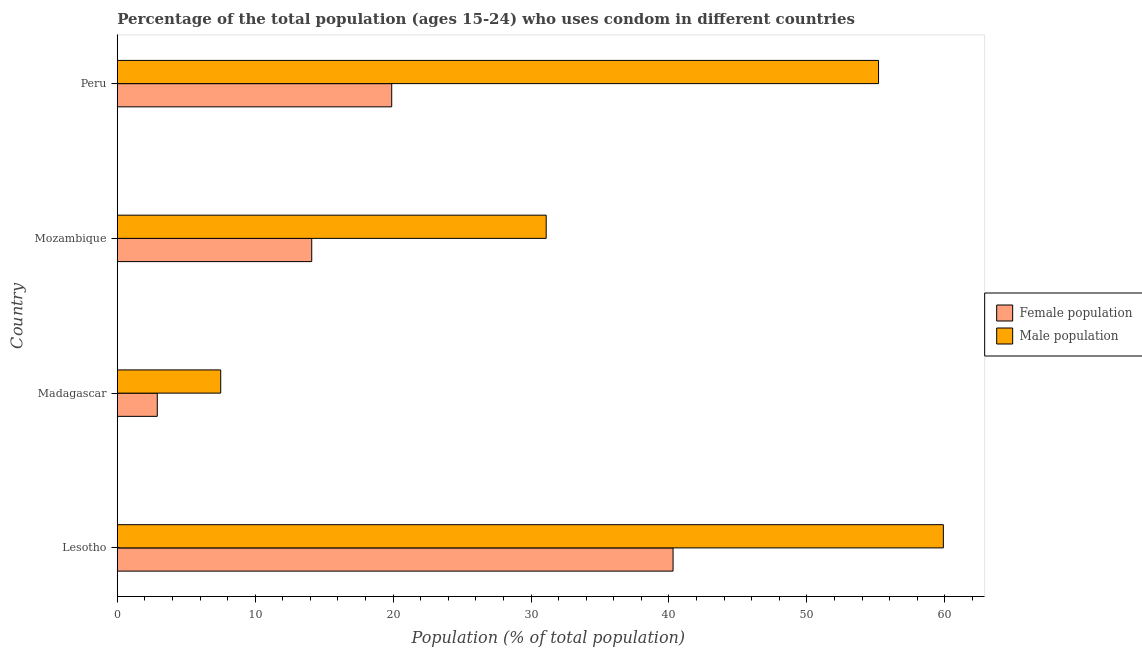How many groups of bars are there?
Make the answer very short. 4. Are the number of bars on each tick of the Y-axis equal?
Your response must be concise. Yes. How many bars are there on the 2nd tick from the bottom?
Offer a terse response. 2. What is the label of the 4th group of bars from the top?
Offer a very short reply. Lesotho. What is the male population in Lesotho?
Provide a short and direct response. 59.9. Across all countries, what is the maximum female population?
Your answer should be compact. 40.3. In which country was the male population maximum?
Make the answer very short. Lesotho. In which country was the male population minimum?
Your response must be concise. Madagascar. What is the total male population in the graph?
Ensure brevity in your answer.  153.7. What is the difference between the female population in Lesotho and that in Mozambique?
Your answer should be compact. 26.2. What is the difference between the male population in Mozambique and the female population in Peru?
Offer a very short reply. 11.2. What is the average male population per country?
Provide a succinct answer. 38.42. What is the ratio of the female population in Lesotho to that in Peru?
Your answer should be compact. 2.02. Is the male population in Madagascar less than that in Peru?
Your response must be concise. Yes. Is the difference between the male population in Lesotho and Mozambique greater than the difference between the female population in Lesotho and Mozambique?
Your answer should be very brief. Yes. What is the difference between the highest and the second highest male population?
Your answer should be compact. 4.7. What is the difference between the highest and the lowest female population?
Keep it short and to the point. 37.4. What does the 1st bar from the top in Peru represents?
Provide a succinct answer. Male population. What does the 1st bar from the bottom in Mozambique represents?
Your response must be concise. Female population. Are all the bars in the graph horizontal?
Ensure brevity in your answer.  Yes. How many countries are there in the graph?
Offer a very short reply. 4. How are the legend labels stacked?
Provide a short and direct response. Vertical. What is the title of the graph?
Ensure brevity in your answer.  Percentage of the total population (ages 15-24) who uses condom in different countries. What is the label or title of the X-axis?
Offer a very short reply. Population (% of total population) . What is the label or title of the Y-axis?
Make the answer very short. Country. What is the Population (% of total population)  in Female population in Lesotho?
Give a very brief answer. 40.3. What is the Population (% of total population)  in Male population in Lesotho?
Make the answer very short. 59.9. What is the Population (% of total population)  of Male population in Madagascar?
Provide a short and direct response. 7.5. What is the Population (% of total population)  of Female population in Mozambique?
Your answer should be very brief. 14.1. What is the Population (% of total population)  of Male population in Mozambique?
Offer a very short reply. 31.1. What is the Population (% of total population)  in Female population in Peru?
Ensure brevity in your answer.  19.9. What is the Population (% of total population)  of Male population in Peru?
Your answer should be compact. 55.2. Across all countries, what is the maximum Population (% of total population)  in Female population?
Offer a terse response. 40.3. Across all countries, what is the maximum Population (% of total population)  of Male population?
Provide a short and direct response. 59.9. Across all countries, what is the minimum Population (% of total population)  of Female population?
Keep it short and to the point. 2.9. What is the total Population (% of total population)  of Female population in the graph?
Keep it short and to the point. 77.2. What is the total Population (% of total population)  of Male population in the graph?
Your answer should be compact. 153.7. What is the difference between the Population (% of total population)  of Female population in Lesotho and that in Madagascar?
Offer a very short reply. 37.4. What is the difference between the Population (% of total population)  in Male population in Lesotho and that in Madagascar?
Your answer should be compact. 52.4. What is the difference between the Population (% of total population)  in Female population in Lesotho and that in Mozambique?
Your answer should be very brief. 26.2. What is the difference between the Population (% of total population)  in Male population in Lesotho and that in Mozambique?
Your response must be concise. 28.8. What is the difference between the Population (% of total population)  in Female population in Lesotho and that in Peru?
Offer a very short reply. 20.4. What is the difference between the Population (% of total population)  in Male population in Madagascar and that in Mozambique?
Offer a terse response. -23.6. What is the difference between the Population (% of total population)  of Female population in Madagascar and that in Peru?
Offer a terse response. -17. What is the difference between the Population (% of total population)  of Male population in Madagascar and that in Peru?
Keep it short and to the point. -47.7. What is the difference between the Population (% of total population)  in Male population in Mozambique and that in Peru?
Your answer should be very brief. -24.1. What is the difference between the Population (% of total population)  of Female population in Lesotho and the Population (% of total population)  of Male population in Madagascar?
Offer a very short reply. 32.8. What is the difference between the Population (% of total population)  in Female population in Lesotho and the Population (% of total population)  in Male population in Mozambique?
Your answer should be very brief. 9.2. What is the difference between the Population (% of total population)  of Female population in Lesotho and the Population (% of total population)  of Male population in Peru?
Your answer should be compact. -14.9. What is the difference between the Population (% of total population)  in Female population in Madagascar and the Population (% of total population)  in Male population in Mozambique?
Provide a short and direct response. -28.2. What is the difference between the Population (% of total population)  of Female population in Madagascar and the Population (% of total population)  of Male population in Peru?
Provide a short and direct response. -52.3. What is the difference between the Population (% of total population)  of Female population in Mozambique and the Population (% of total population)  of Male population in Peru?
Offer a terse response. -41.1. What is the average Population (% of total population)  of Female population per country?
Ensure brevity in your answer.  19.3. What is the average Population (% of total population)  of Male population per country?
Ensure brevity in your answer.  38.42. What is the difference between the Population (% of total population)  of Female population and Population (% of total population)  of Male population in Lesotho?
Offer a very short reply. -19.6. What is the difference between the Population (% of total population)  in Female population and Population (% of total population)  in Male population in Madagascar?
Ensure brevity in your answer.  -4.6. What is the difference between the Population (% of total population)  in Female population and Population (% of total population)  in Male population in Mozambique?
Provide a succinct answer. -17. What is the difference between the Population (% of total population)  in Female population and Population (% of total population)  in Male population in Peru?
Keep it short and to the point. -35.3. What is the ratio of the Population (% of total population)  in Female population in Lesotho to that in Madagascar?
Make the answer very short. 13.9. What is the ratio of the Population (% of total population)  of Male population in Lesotho to that in Madagascar?
Provide a succinct answer. 7.99. What is the ratio of the Population (% of total population)  of Female population in Lesotho to that in Mozambique?
Your answer should be very brief. 2.86. What is the ratio of the Population (% of total population)  in Male population in Lesotho to that in Mozambique?
Provide a succinct answer. 1.93. What is the ratio of the Population (% of total population)  in Female population in Lesotho to that in Peru?
Make the answer very short. 2.03. What is the ratio of the Population (% of total population)  in Male population in Lesotho to that in Peru?
Make the answer very short. 1.09. What is the ratio of the Population (% of total population)  of Female population in Madagascar to that in Mozambique?
Your answer should be very brief. 0.21. What is the ratio of the Population (% of total population)  in Male population in Madagascar to that in Mozambique?
Your answer should be compact. 0.24. What is the ratio of the Population (% of total population)  in Female population in Madagascar to that in Peru?
Keep it short and to the point. 0.15. What is the ratio of the Population (% of total population)  in Male population in Madagascar to that in Peru?
Ensure brevity in your answer.  0.14. What is the ratio of the Population (% of total population)  of Female population in Mozambique to that in Peru?
Make the answer very short. 0.71. What is the ratio of the Population (% of total population)  of Male population in Mozambique to that in Peru?
Ensure brevity in your answer.  0.56. What is the difference between the highest and the second highest Population (% of total population)  in Female population?
Ensure brevity in your answer.  20.4. What is the difference between the highest and the lowest Population (% of total population)  in Female population?
Keep it short and to the point. 37.4. What is the difference between the highest and the lowest Population (% of total population)  in Male population?
Provide a succinct answer. 52.4. 